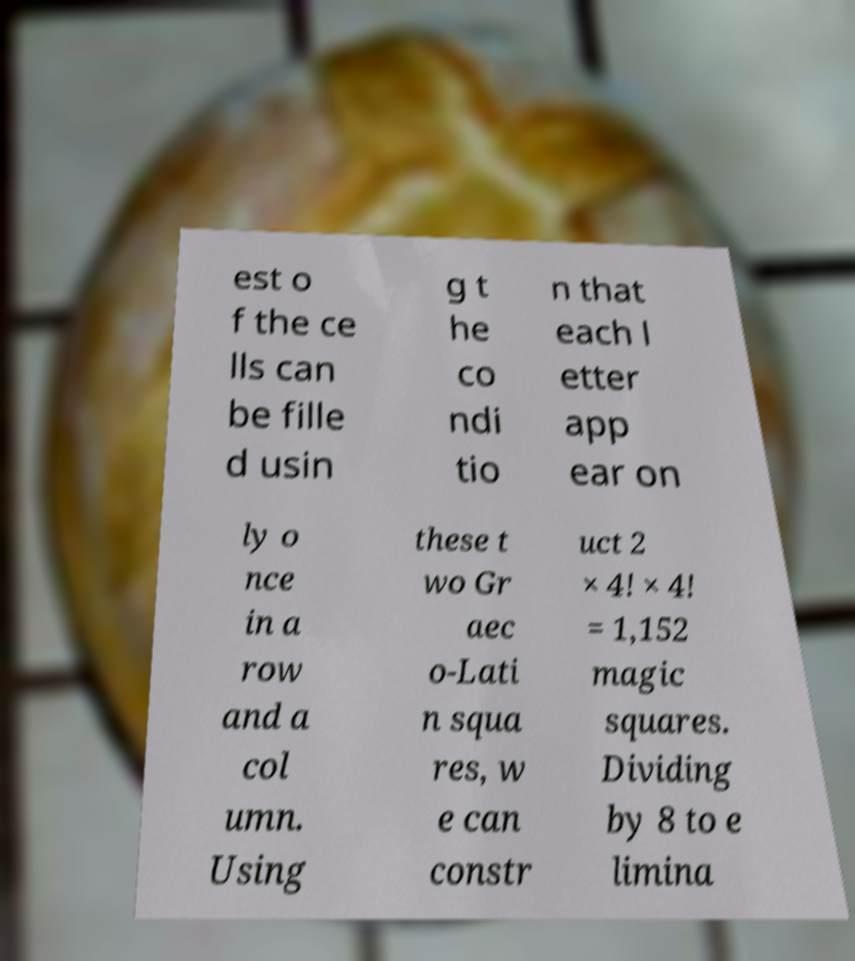Can you accurately transcribe the text from the provided image for me? est o f the ce lls can be fille d usin g t he co ndi tio n that each l etter app ear on ly o nce in a row and a col umn. Using these t wo Gr aec o-Lati n squa res, w e can constr uct 2 × 4! × 4! = 1,152 magic squares. Dividing by 8 to e limina 